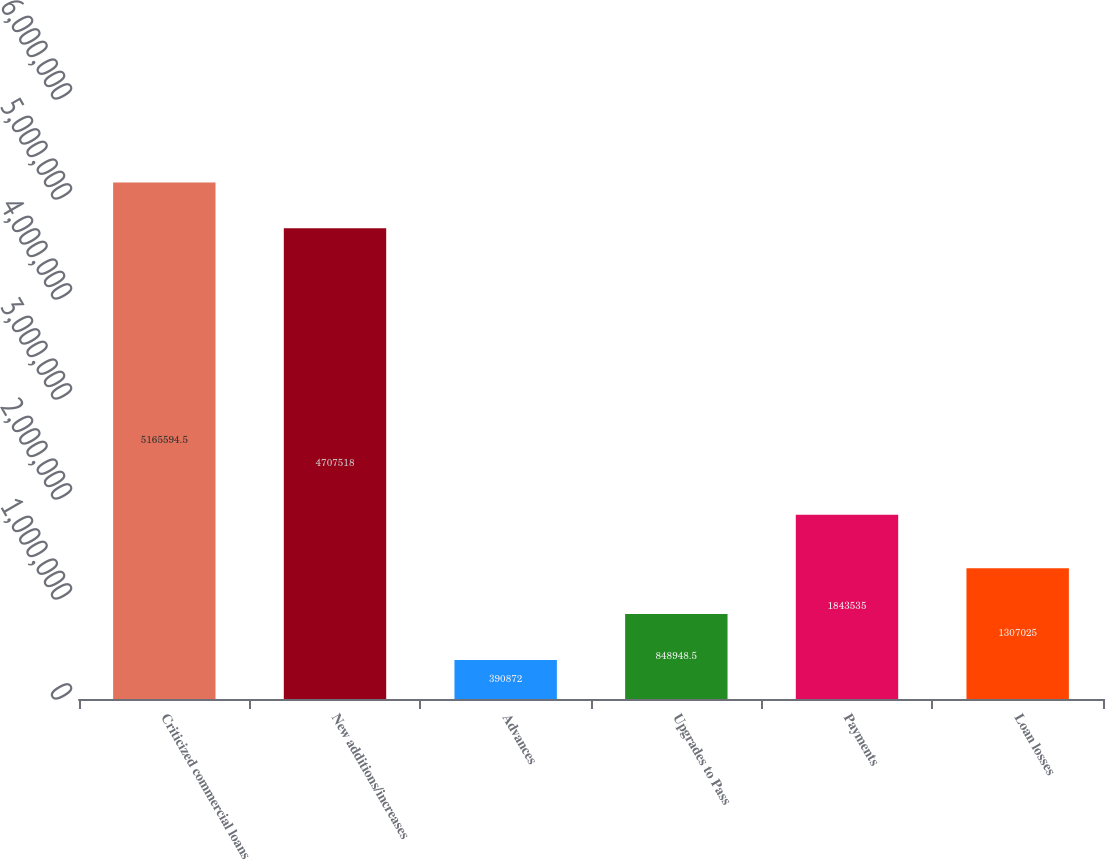Convert chart to OTSL. <chart><loc_0><loc_0><loc_500><loc_500><bar_chart><fcel>Criticized commercial loans<fcel>New additions/increases<fcel>Advances<fcel>Upgrades to Pass<fcel>Payments<fcel>Loan losses<nl><fcel>5.16559e+06<fcel>4.70752e+06<fcel>390872<fcel>848948<fcel>1.84354e+06<fcel>1.30702e+06<nl></chart> 